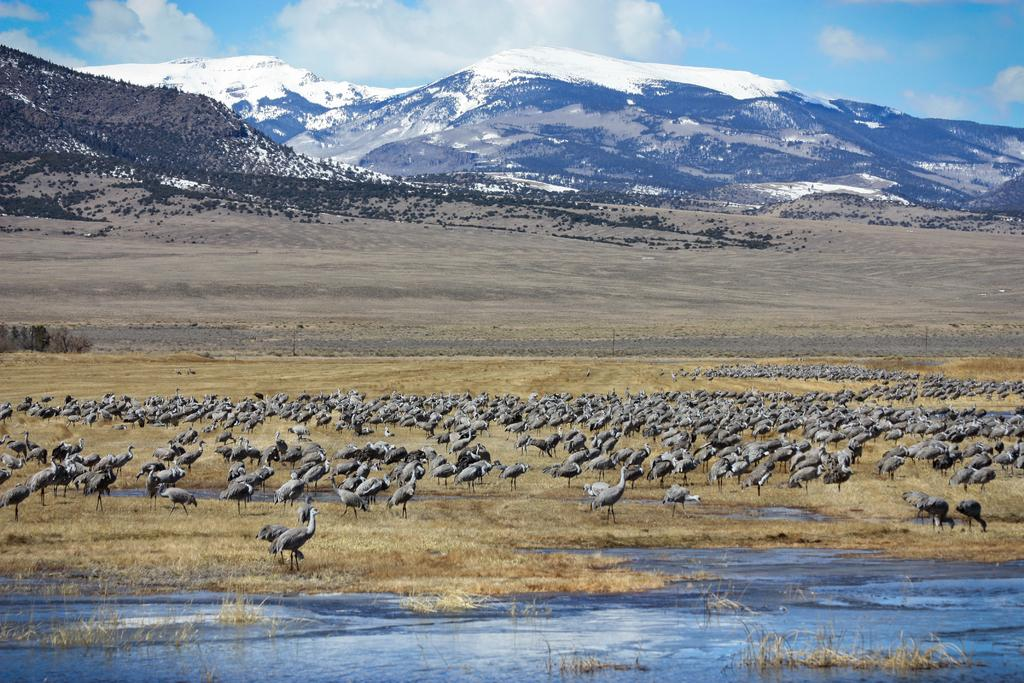What type of animals can be seen on the ground in the image? There are birds on the ground in the image. What is visible in the image besides the birds? There is water, mountains, and the sky visible in the image. What is the condition of the sky in the image? The sky is visible in the background of the image, and clouds are present. What type of peace symbol can be seen in the image? There is no peace symbol present in the image; it features birds on the ground, water, mountains, and a sky with clouds. Can you tell me which actor is depicted in the image? There is no actor present in the image; it features birds, water, mountains, and a sky with clouds. 